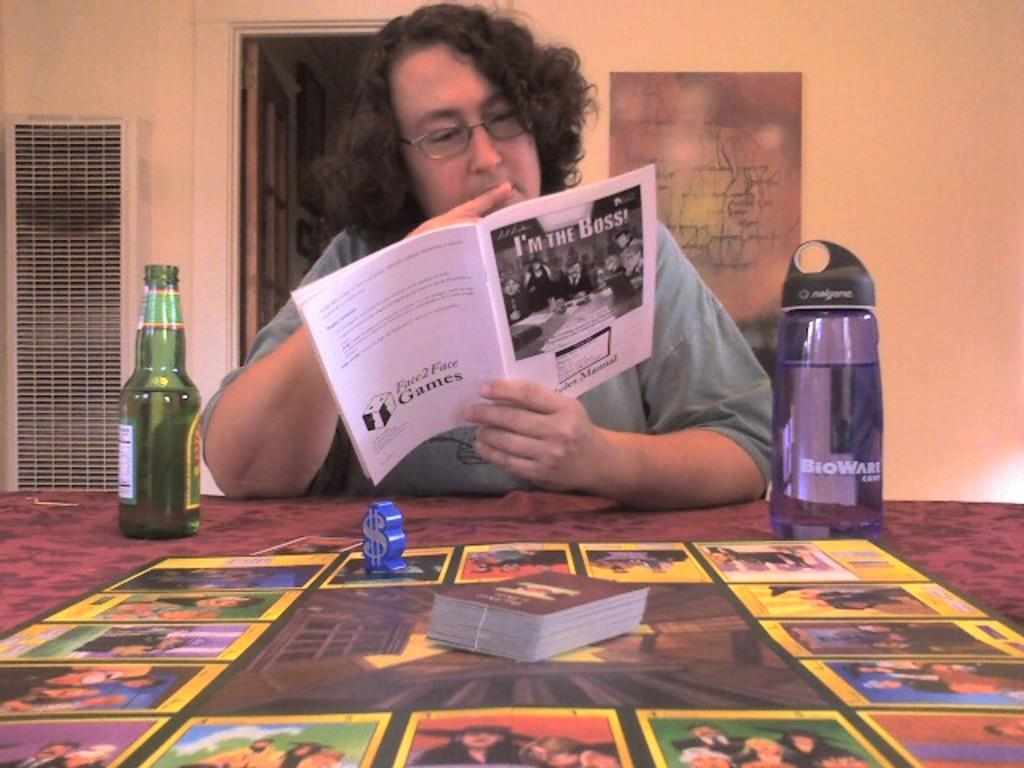<image>
Create a compact narrative representing the image presented. A person reads I'm the Boss at a table with a board game. 